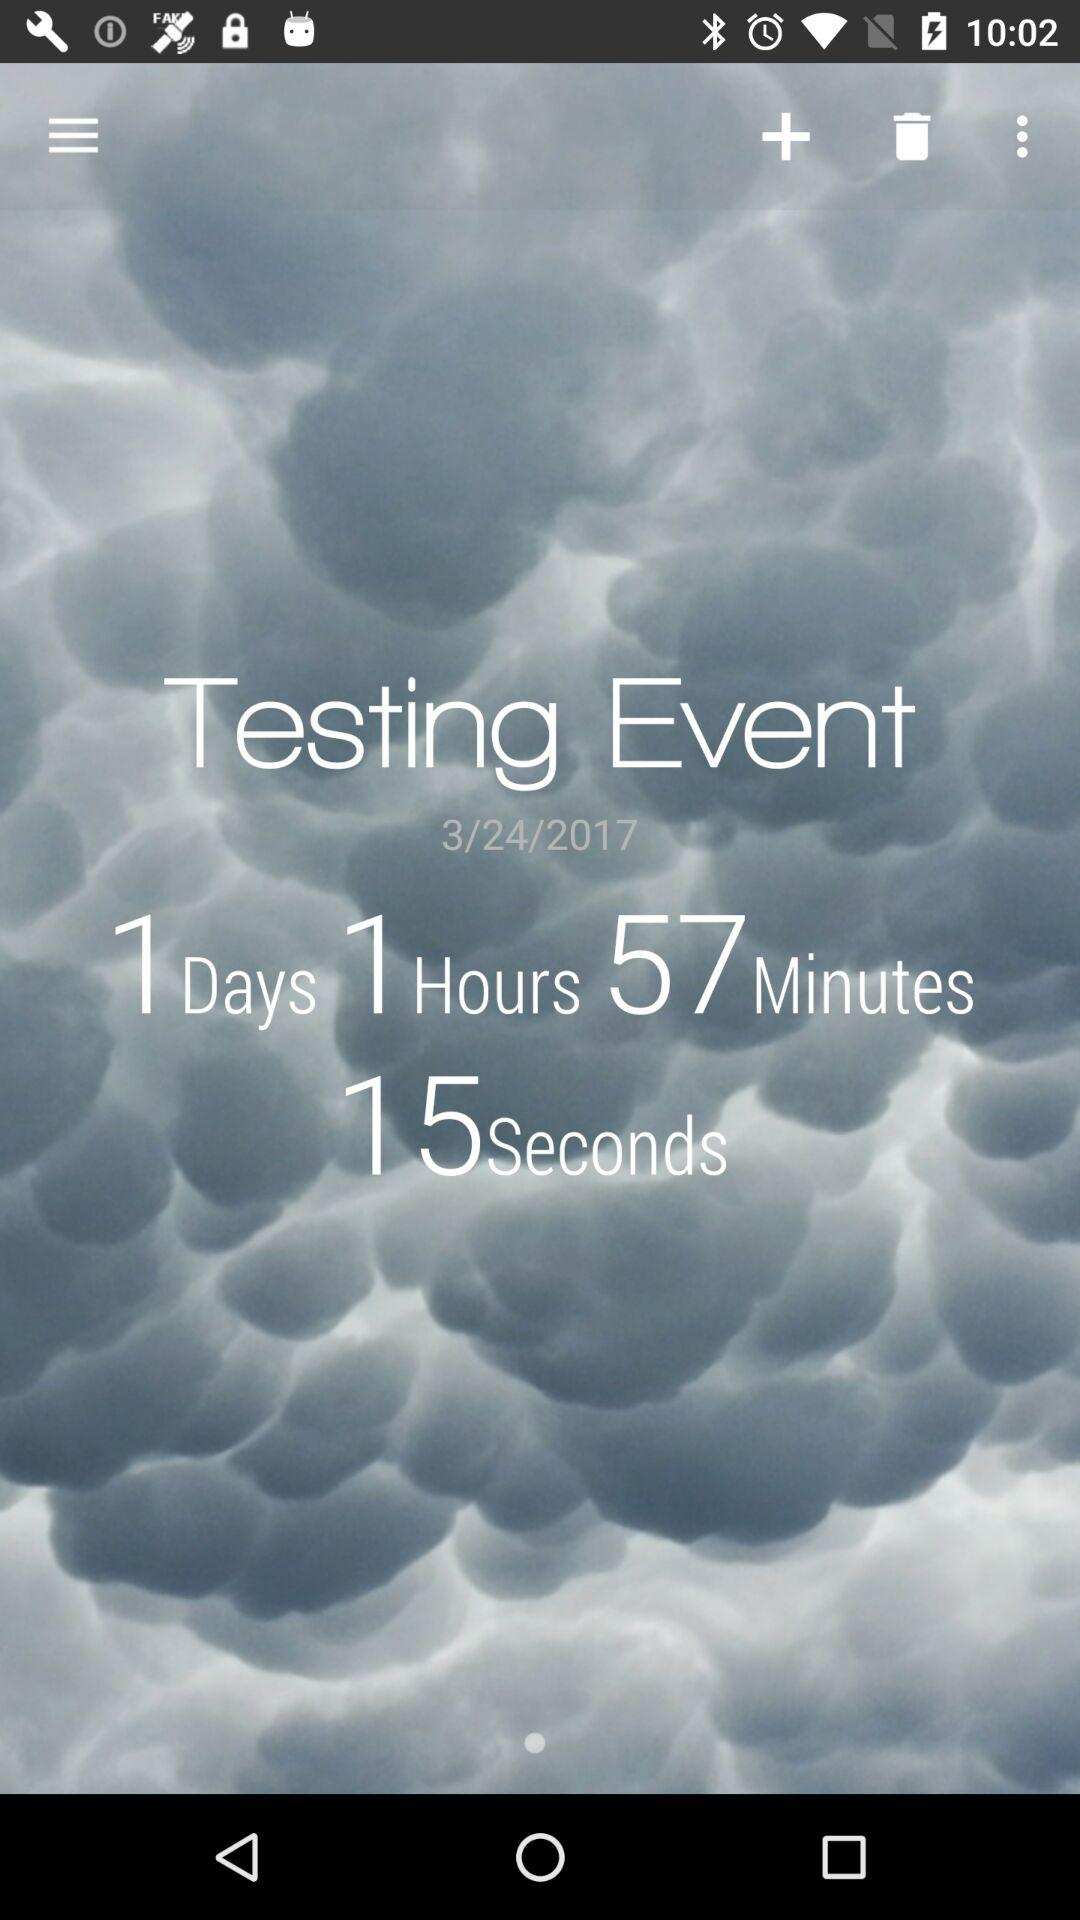How much time is left for the event to be held? The time left for the event is 1 day 1 hour 57 minutes 15 seconds. 